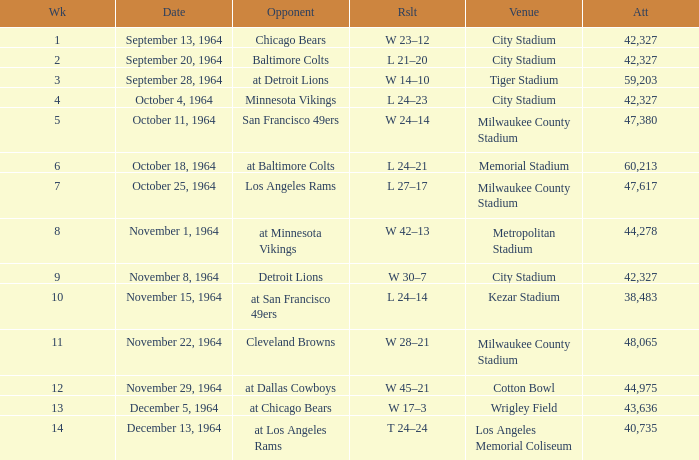What is the average attendance at a week 4 game? 42327.0. 